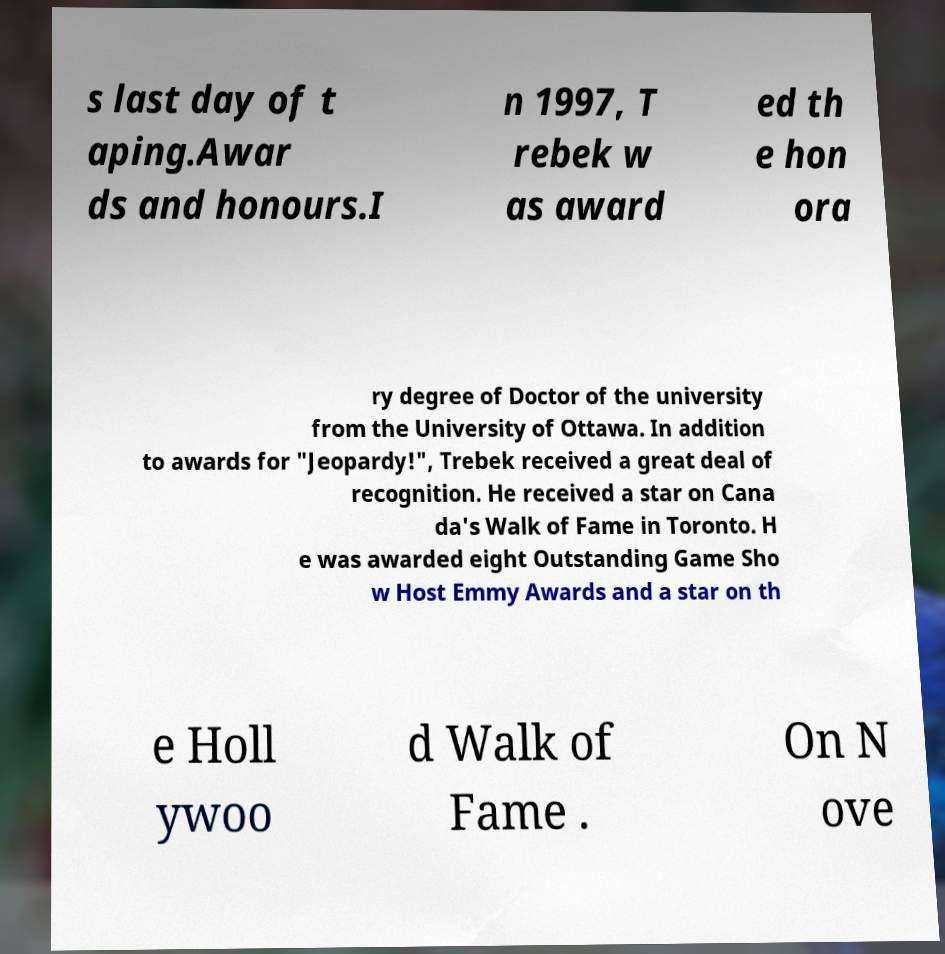Can you accurately transcribe the text from the provided image for me? s last day of t aping.Awar ds and honours.I n 1997, T rebek w as award ed th e hon ora ry degree of Doctor of the university from the University of Ottawa. In addition to awards for "Jeopardy!", Trebek received a great deal of recognition. He received a star on Cana da's Walk of Fame in Toronto. H e was awarded eight Outstanding Game Sho w Host Emmy Awards and a star on th e Holl ywoo d Walk of Fame . On N ove 